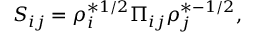<formula> <loc_0><loc_0><loc_500><loc_500>S _ { i j } = \rho _ { i } ^ { * 1 / 2 } \Pi _ { i j } \rho _ { j } ^ { * - 1 / 2 } ,</formula> 